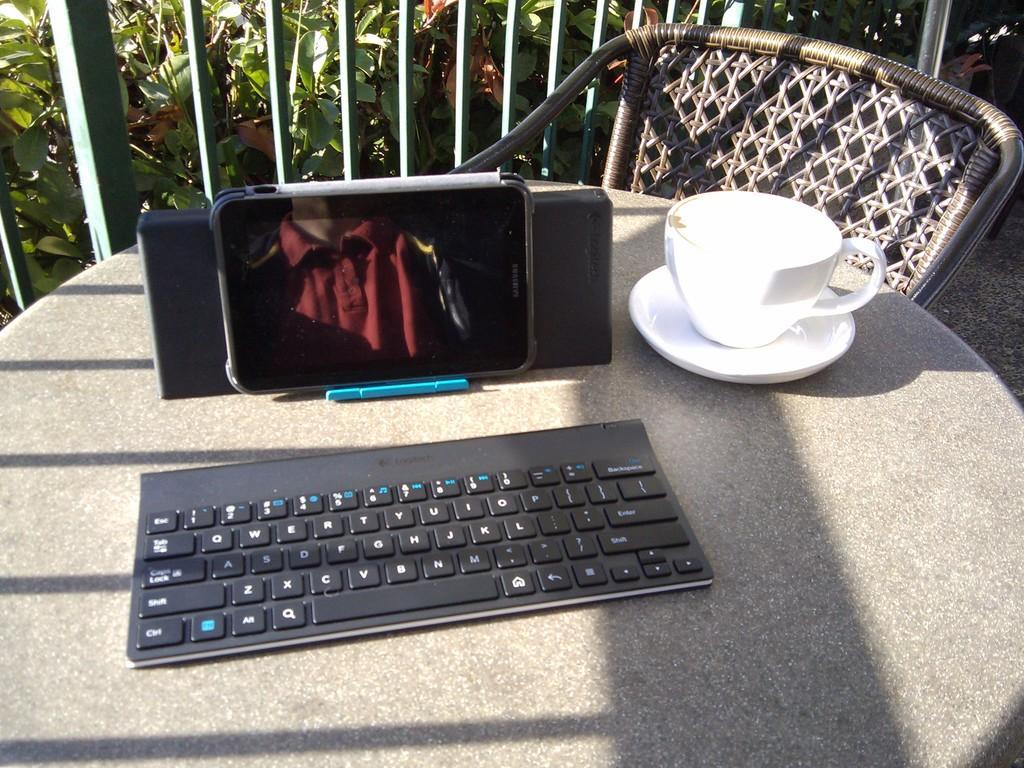Can you describe this image briefly? In this image, we can see a table with some objects like a keyboard, a cup and a mobile phone. We can also see a blue colored object. We can see a chair and some poles. There are a few plants and we can see the ground. 